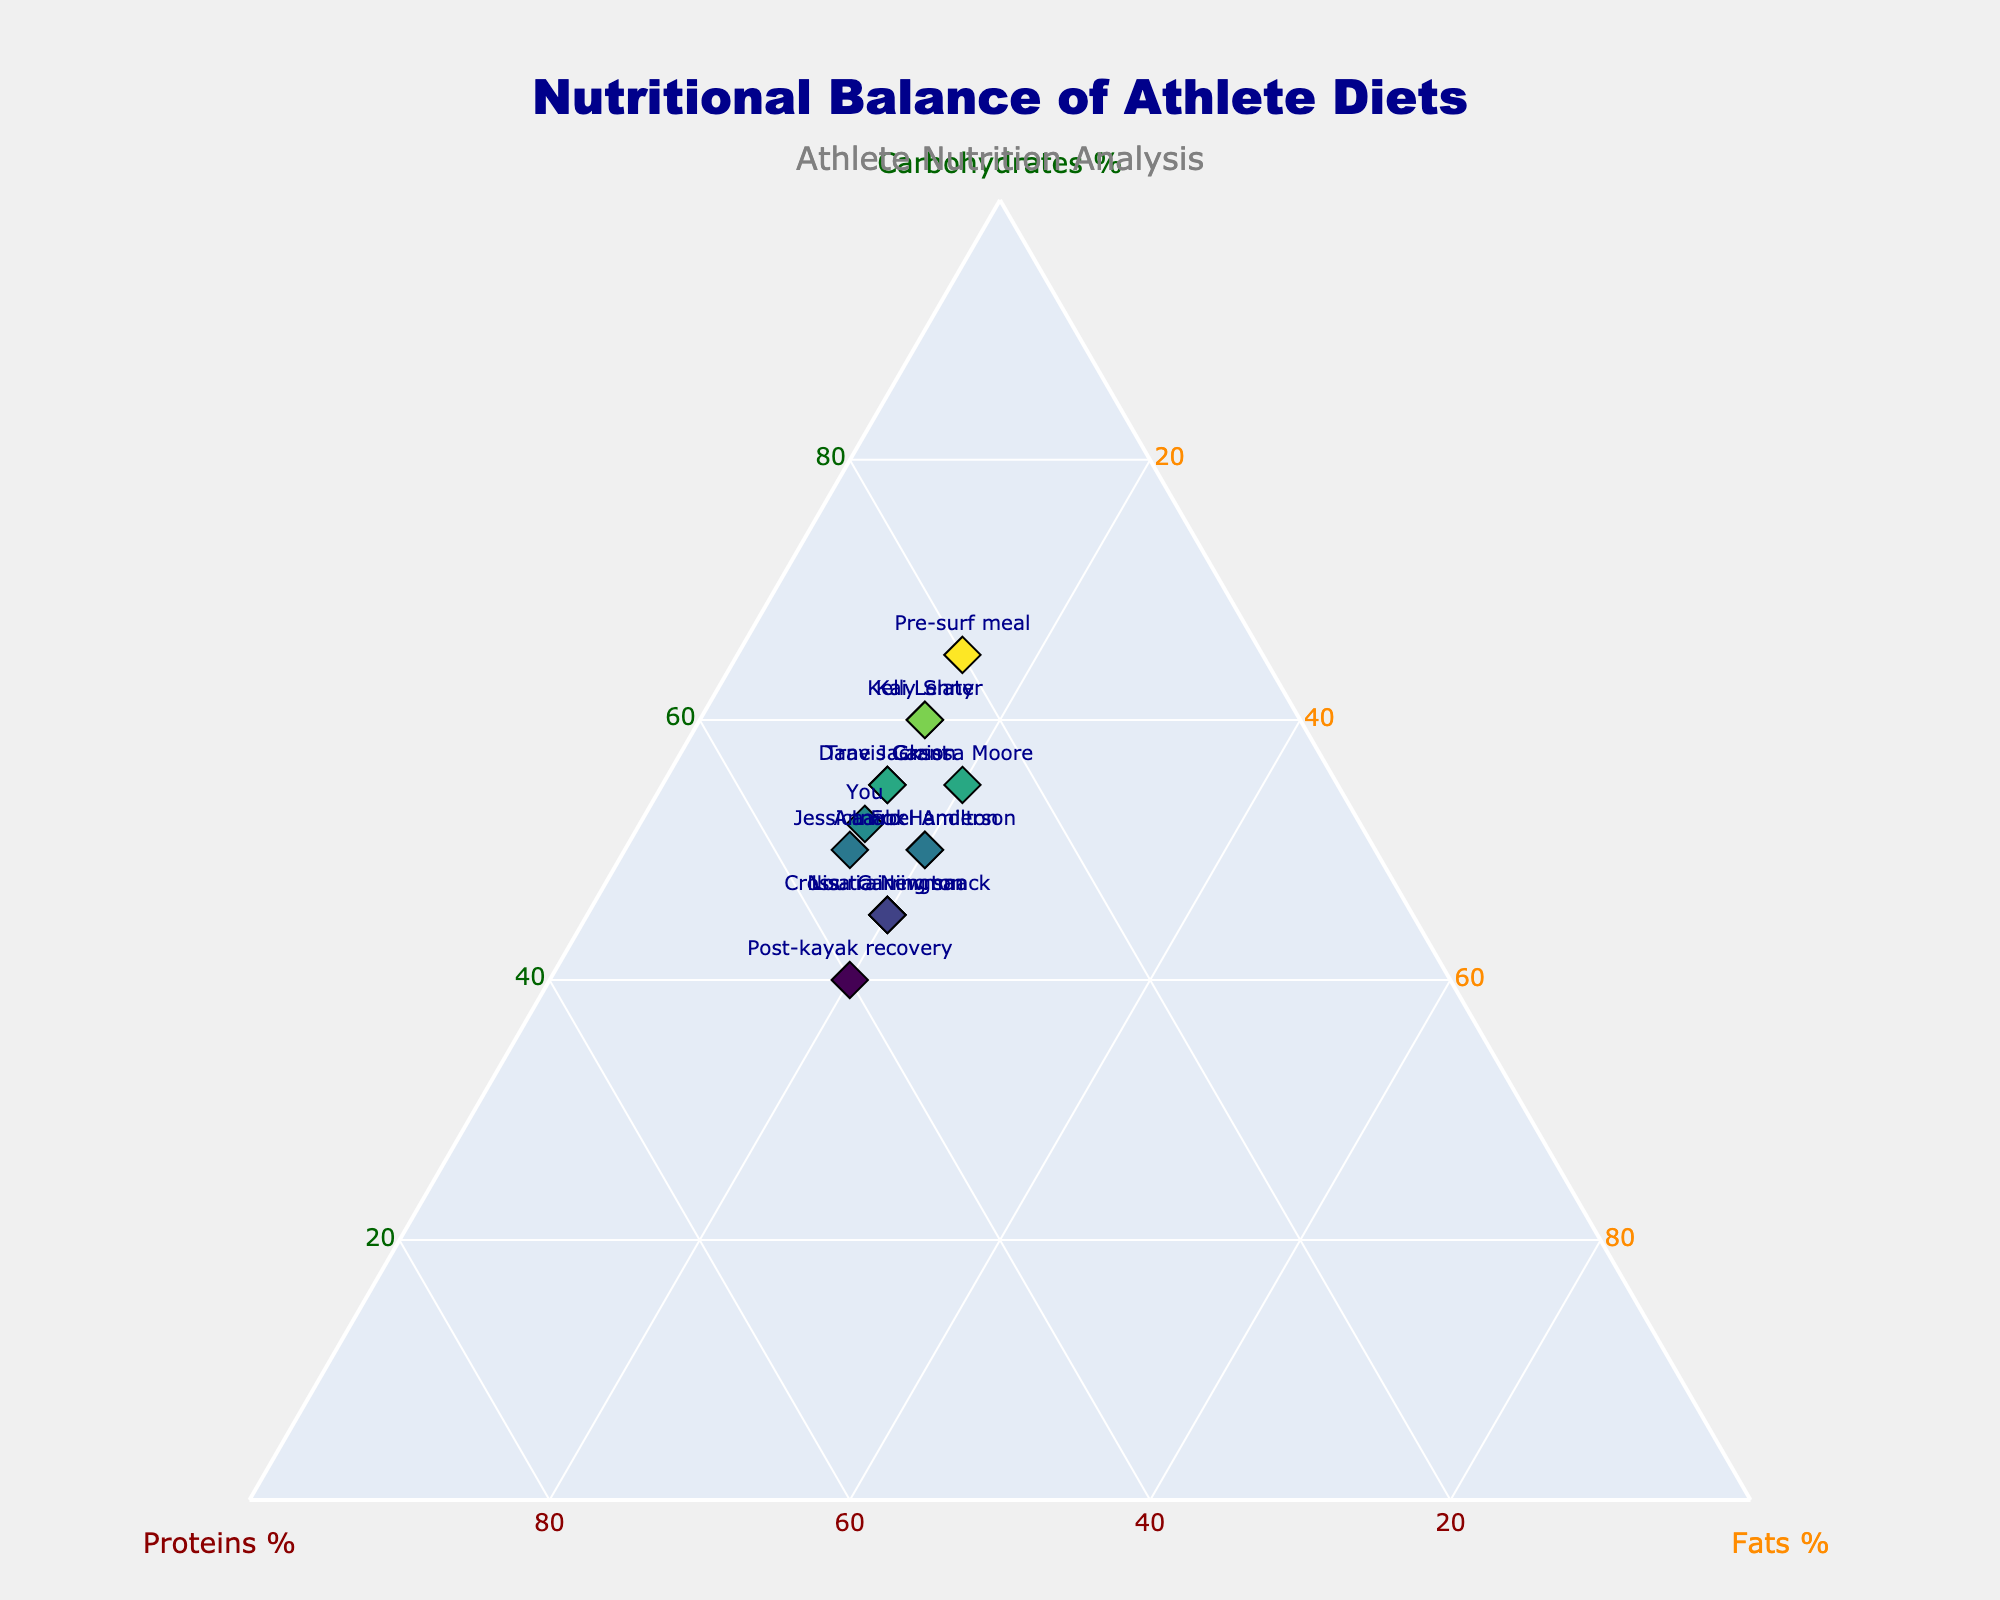what is the title of the figure? The title of the figure can be found at the top and it is usually larger and more prominently displayed than other text elements.
Answer: Nutritional Balance of Athlete Diets what nutrients do the ternary plot axes represent? The ternary plot three axes each represent a different nutrient and are labeled at the tips of the triangular plot.
Answer: Carbohydrates, Proteins, and Fats which athlete has the highest proportion of proteins? By examining the plot and looking at the data point located closest to the 'Proteins' axis, we can determine the athlete.
Answer: Post-kayak recovery which athlete has a diet closest to an equal balance of carbohydrates, proteins, and fats? An equal balance would place an athlete near the center of the ternary plot, so we need to look for the data point closest to the center.
Answer: Post-kayak recovery how many athletes have a carbohydrate percentage of 55? By reviewing the plot and counting the markers at the 55% carbohydrate level, we can identify the number of athletes.
Answer: Three compare the fat percentages of Annabel Anderson and Kai Lenny. Who has a higher fat intake? Observe the respective positions of Annabel Anderson and Kai Lenny on the plot and compare their fat percentages, noting which is higher.
Answer: Annabel Anderson what is the combined protein percentage of Jessica Fox and Lisa Carrington? Add the protein percentages from both athletes: Jessica Fox has 35% and Lisa Carrington has 35%.
Answer: 70% which diet is closest to your own nutritional balance? Find the data point labeled 'You' and compare its position to all other points, determining the nearest one.
Answer: Jessica Fox what's the difference in carbohydrate intake between Carissa Moore and Travis Grant? Subtract the carbohydrate percentage of one from the other: Carissa Moore has 55% and Travis Grant has 55%.
Answer: 0% which pre-post meal has the highest percentage of carbohydrates? Locate the data points labeled 'Pre-surf meal,' 'Post-kayak recovery,' and 'Cross-training snack,' and find the one with the highest carbohydrate percentage.
Answer: Pre-surf meal 